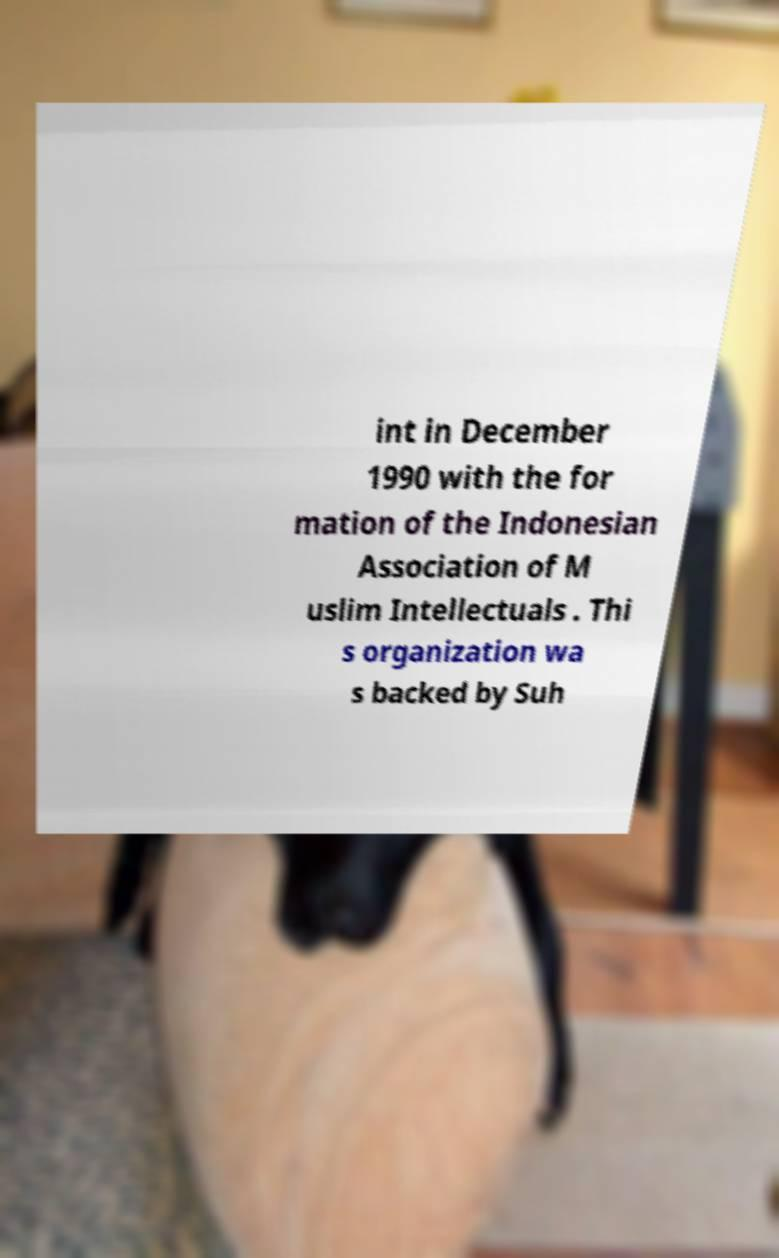Please read and relay the text visible in this image. What does it say? int in December 1990 with the for mation of the Indonesian Association of M uslim Intellectuals . Thi s organization wa s backed by Suh 